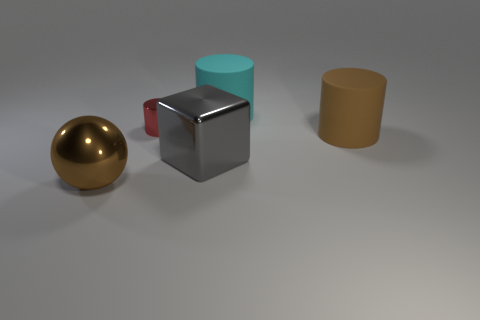Subtract all green cylinders. Subtract all cyan balls. How many cylinders are left? 3 Add 3 small blue metal things. How many objects exist? 8 Subtract all cylinders. How many objects are left? 2 Subtract 0 red blocks. How many objects are left? 5 Subtract all matte balls. Subtract all red metallic cylinders. How many objects are left? 4 Add 4 large cyan rubber things. How many large cyan rubber things are left? 5 Add 1 small yellow shiny cylinders. How many small yellow shiny cylinders exist? 1 